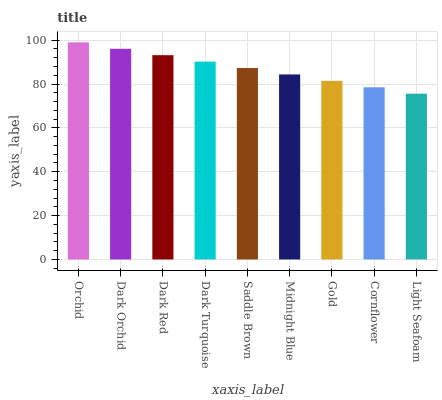Is Dark Orchid the minimum?
Answer yes or no. No. Is Dark Orchid the maximum?
Answer yes or no. No. Is Orchid greater than Dark Orchid?
Answer yes or no. Yes. Is Dark Orchid less than Orchid?
Answer yes or no. Yes. Is Dark Orchid greater than Orchid?
Answer yes or no. No. Is Orchid less than Dark Orchid?
Answer yes or no. No. Is Saddle Brown the high median?
Answer yes or no. Yes. Is Saddle Brown the low median?
Answer yes or no. Yes. Is Orchid the high median?
Answer yes or no. No. Is Light Seafoam the low median?
Answer yes or no. No. 